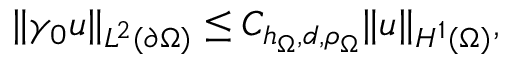<formula> <loc_0><loc_0><loc_500><loc_500>\| \gamma _ { 0 } u \| _ { L ^ { 2 } ( \partial \Omega ) } \leq C _ { h _ { \Omega } , d , \rho _ { \Omega } } \| u \| _ { H ^ { 1 } ( \Omega ) } ,</formula> 